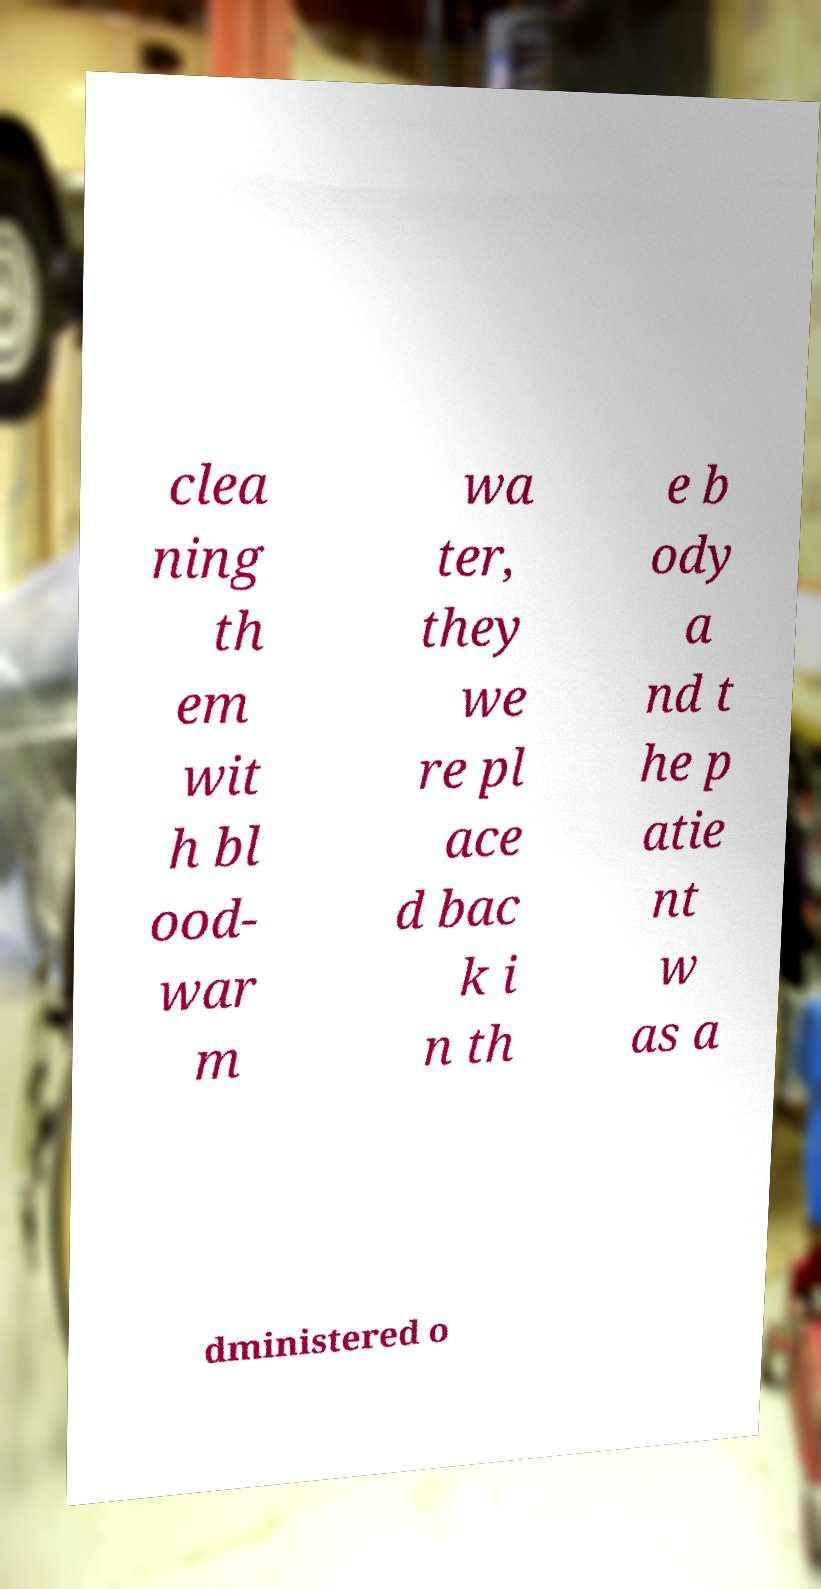I need the written content from this picture converted into text. Can you do that? clea ning th em wit h bl ood- war m wa ter, they we re pl ace d bac k i n th e b ody a nd t he p atie nt w as a dministered o 